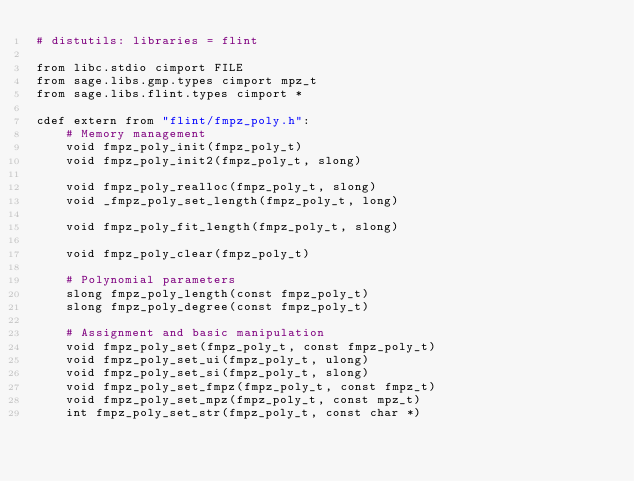Convert code to text. <code><loc_0><loc_0><loc_500><loc_500><_Cython_># distutils: libraries = flint

from libc.stdio cimport FILE
from sage.libs.gmp.types cimport mpz_t
from sage.libs.flint.types cimport *

cdef extern from "flint/fmpz_poly.h":
    # Memory management
    void fmpz_poly_init(fmpz_poly_t)
    void fmpz_poly_init2(fmpz_poly_t, slong)

    void fmpz_poly_realloc(fmpz_poly_t, slong)
    void _fmpz_poly_set_length(fmpz_poly_t, long)

    void fmpz_poly_fit_length(fmpz_poly_t, slong)

    void fmpz_poly_clear(fmpz_poly_t)

    # Polynomial parameters
    slong fmpz_poly_length(const fmpz_poly_t)
    slong fmpz_poly_degree(const fmpz_poly_t)

    # Assignment and basic manipulation
    void fmpz_poly_set(fmpz_poly_t, const fmpz_poly_t)
    void fmpz_poly_set_ui(fmpz_poly_t, ulong)
    void fmpz_poly_set_si(fmpz_poly_t, slong)
    void fmpz_poly_set_fmpz(fmpz_poly_t, const fmpz_t)
    void fmpz_poly_set_mpz(fmpz_poly_t, const mpz_t)
    int fmpz_poly_set_str(fmpz_poly_t, const char *)
</code> 